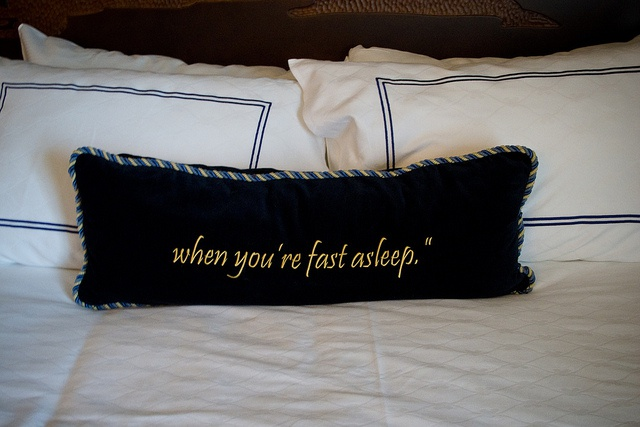Describe the objects in this image and their specific colors. I can see a bed in darkgray, black, and gray tones in this image. 